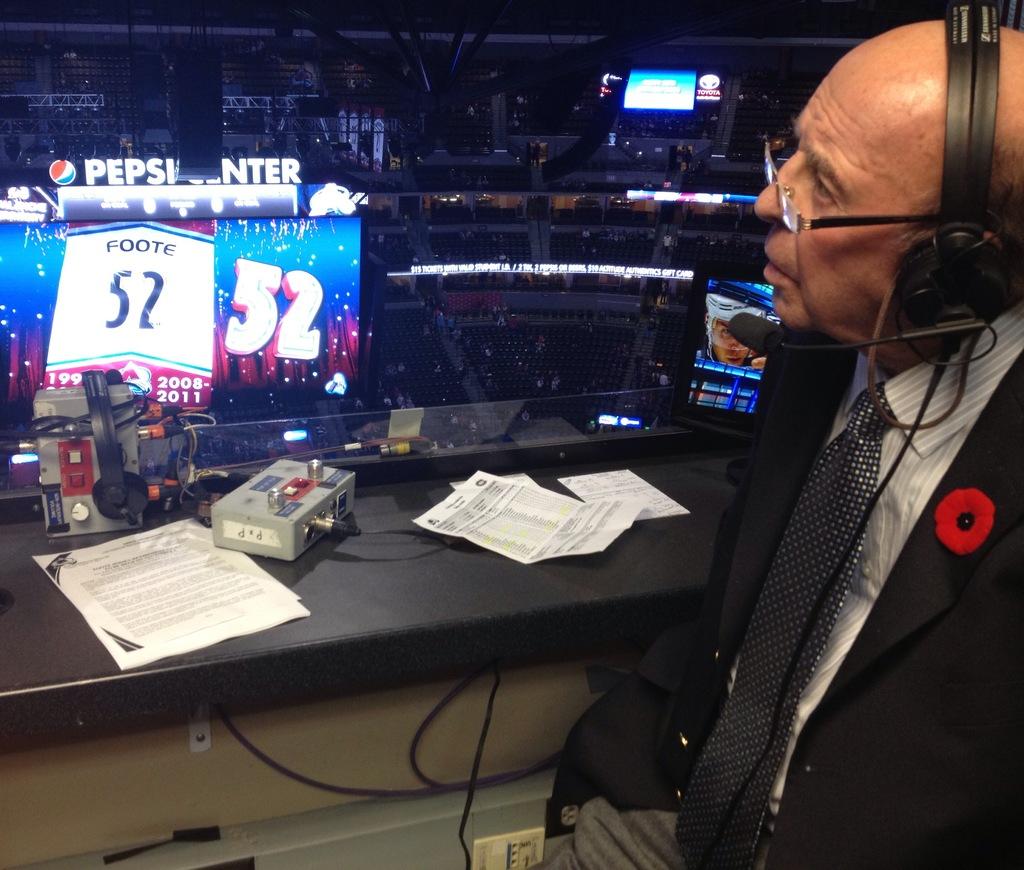What soft drink brand is sponsoring this event?
Offer a terse response. Pepsi. What numbers are seen to the left?
Provide a succinct answer. 52. 